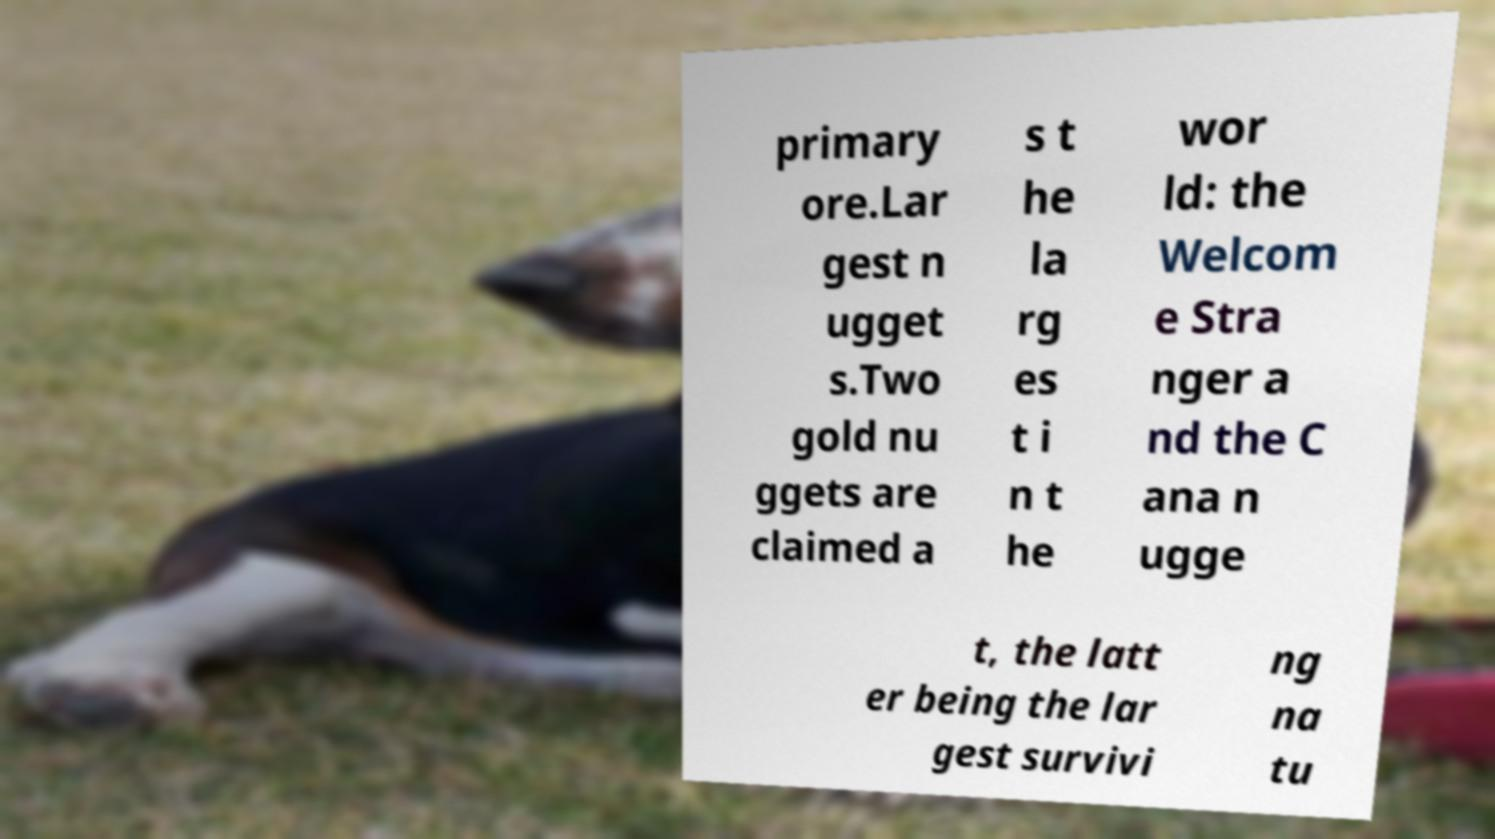Can you accurately transcribe the text from the provided image for me? primary ore.Lar gest n ugget s.Two gold nu ggets are claimed a s t he la rg es t i n t he wor ld: the Welcom e Stra nger a nd the C ana n ugge t, the latt er being the lar gest survivi ng na tu 